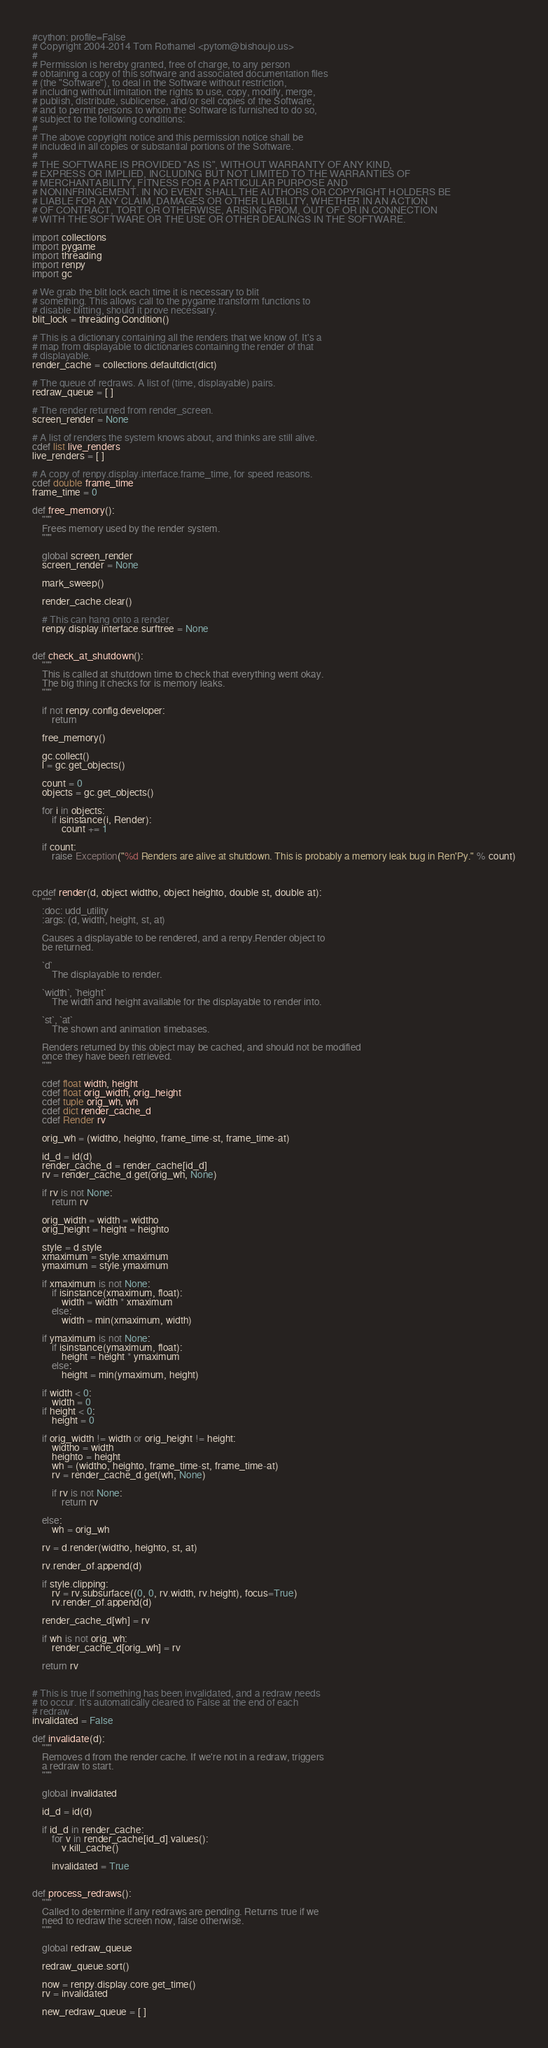<code> <loc_0><loc_0><loc_500><loc_500><_Cython_>#cython: profile=False
# Copyright 2004-2014 Tom Rothamel <pytom@bishoujo.us>
#
# Permission is hereby granted, free of charge, to any person
# obtaining a copy of this software and associated documentation files
# (the "Software"), to deal in the Software without restriction,
# including without limitation the rights to use, copy, modify, merge,
# publish, distribute, sublicense, and/or sell copies of the Software,
# and to permit persons to whom the Software is furnished to do so,
# subject to the following conditions:
#
# The above copyright notice and this permission notice shall be
# included in all copies or substantial portions of the Software.
#
# THE SOFTWARE IS PROVIDED "AS IS", WITHOUT WARRANTY OF ANY KIND,
# EXPRESS OR IMPLIED, INCLUDING BUT NOT LIMITED TO THE WARRANTIES OF
# MERCHANTABILITY, FITNESS FOR A PARTICULAR PURPOSE AND
# NONINFRINGEMENT. IN NO EVENT SHALL THE AUTHORS OR COPYRIGHT HOLDERS BE
# LIABLE FOR ANY CLAIM, DAMAGES OR OTHER LIABILITY, WHETHER IN AN ACTION
# OF CONTRACT, TORT OR OTHERWISE, ARISING FROM, OUT OF OR IN CONNECTION
# WITH THE SOFTWARE OR THE USE OR OTHER DEALINGS IN THE SOFTWARE.

import collections
import pygame
import threading
import renpy
import gc

# We grab the blit lock each time it is necessary to blit
# something. This allows call to the pygame.transform functions to
# disable blitting, should it prove necessary.
blit_lock = threading.Condition()

# This is a dictionary containing all the renders that we know of. It's a
# map from displayable to dictionaries containing the render of that
# displayable.
render_cache = collections.defaultdict(dict)

# The queue of redraws. A list of (time, displayable) pairs.
redraw_queue = [ ]

# The render returned from render_screen.
screen_render = None

# A list of renders the system knows about, and thinks are still alive.
cdef list live_renders
live_renders = [ ]

# A copy of renpy.display.interface.frame_time, for speed reasons.
cdef double frame_time
frame_time = 0

def free_memory():
    """
    Frees memory used by the render system.
    """

    global screen_render
    screen_render = None

    mark_sweep()

    render_cache.clear()

    # This can hang onto a render.
    renpy.display.interface.surftree = None


def check_at_shutdown():
    """
    This is called at shutdown time to check that everything went okay.
    The big thing it checks for is memory leaks.
    """

    if not renpy.config.developer:
        return

    free_memory()

    gc.collect()
    l = gc.get_objects()

    count = 0
    objects = gc.get_objects()

    for i in objects:
        if isinstance(i, Render):
            count += 1

    if count:
        raise Exception("%d Renders are alive at shutdown. This is probably a memory leak bug in Ren'Py." % count)



cpdef render(d, object widtho, object heighto, double st, double at):
    """
    :doc: udd_utility
    :args: (d, width, height, st, at)

    Causes a displayable to be rendered, and a renpy.Render object to
    be returned.

    `d`
        The displayable to render.

    `width`, `height`
        The width and height available for the displayable to render into.

    `st`, `at`
        The shown and animation timebases.

    Renders returned by this object may be cached, and should not be modified
    once they have been retrieved.
    """

    cdef float width, height
    cdef float orig_width, orig_height
    cdef tuple orig_wh, wh
    cdef dict render_cache_d
    cdef Render rv

    orig_wh = (widtho, heighto, frame_time-st, frame_time-at)

    id_d = id(d)
    render_cache_d = render_cache[id_d]
    rv = render_cache_d.get(orig_wh, None)

    if rv is not None:
        return rv

    orig_width = width = widtho
    orig_height = height = heighto

    style = d.style
    xmaximum = style.xmaximum
    ymaximum = style.ymaximum

    if xmaximum is not None:
        if isinstance(xmaximum, float):
            width = width * xmaximum
        else:
            width = min(xmaximum, width)

    if ymaximum is not None:
        if isinstance(ymaximum, float):
            height = height * ymaximum
        else:
            height = min(ymaximum, height)

    if width < 0:
        width = 0
    if height < 0:
        height = 0

    if orig_width != width or orig_height != height:
        widtho = width
        heighto = height
        wh = (widtho, heighto, frame_time-st, frame_time-at)
        rv = render_cache_d.get(wh, None)

        if rv is not None:
            return rv

    else:
        wh = orig_wh

    rv = d.render(widtho, heighto, st, at)

    rv.render_of.append(d)

    if style.clipping:
        rv = rv.subsurface((0, 0, rv.width, rv.height), focus=True)
        rv.render_of.append(d)

    render_cache_d[wh] = rv

    if wh is not orig_wh:
        render_cache_d[orig_wh] = rv

    return rv


# This is true if something has been invalidated, and a redraw needs
# to occur. It's automatically cleared to False at the end of each
# redraw.
invalidated = False

def invalidate(d):
    """
    Removes d from the render cache. If we're not in a redraw, triggers
    a redraw to start.
    """

    global invalidated

    id_d = id(d)

    if id_d in render_cache:
        for v in render_cache[id_d].values():
            v.kill_cache()

        invalidated = True


def process_redraws():
    """
    Called to determine if any redraws are pending. Returns true if we
    need to redraw the screen now, false otherwise.
    """

    global redraw_queue

    redraw_queue.sort()

    now = renpy.display.core.get_time()
    rv = invalidated

    new_redraw_queue = [ ]</code> 